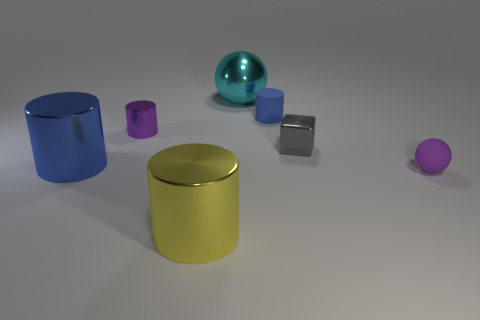Subtract all metal cylinders. How many cylinders are left? 1 Subtract all red cylinders. Subtract all cyan balls. How many cylinders are left? 4 Add 2 blue metallic spheres. How many objects exist? 9 Subtract all cylinders. How many objects are left? 3 Add 7 tiny blue matte cylinders. How many tiny blue matte cylinders exist? 8 Subtract 0 blue cubes. How many objects are left? 7 Subtract all small metal things. Subtract all big balls. How many objects are left? 4 Add 4 tiny purple things. How many tiny purple things are left? 6 